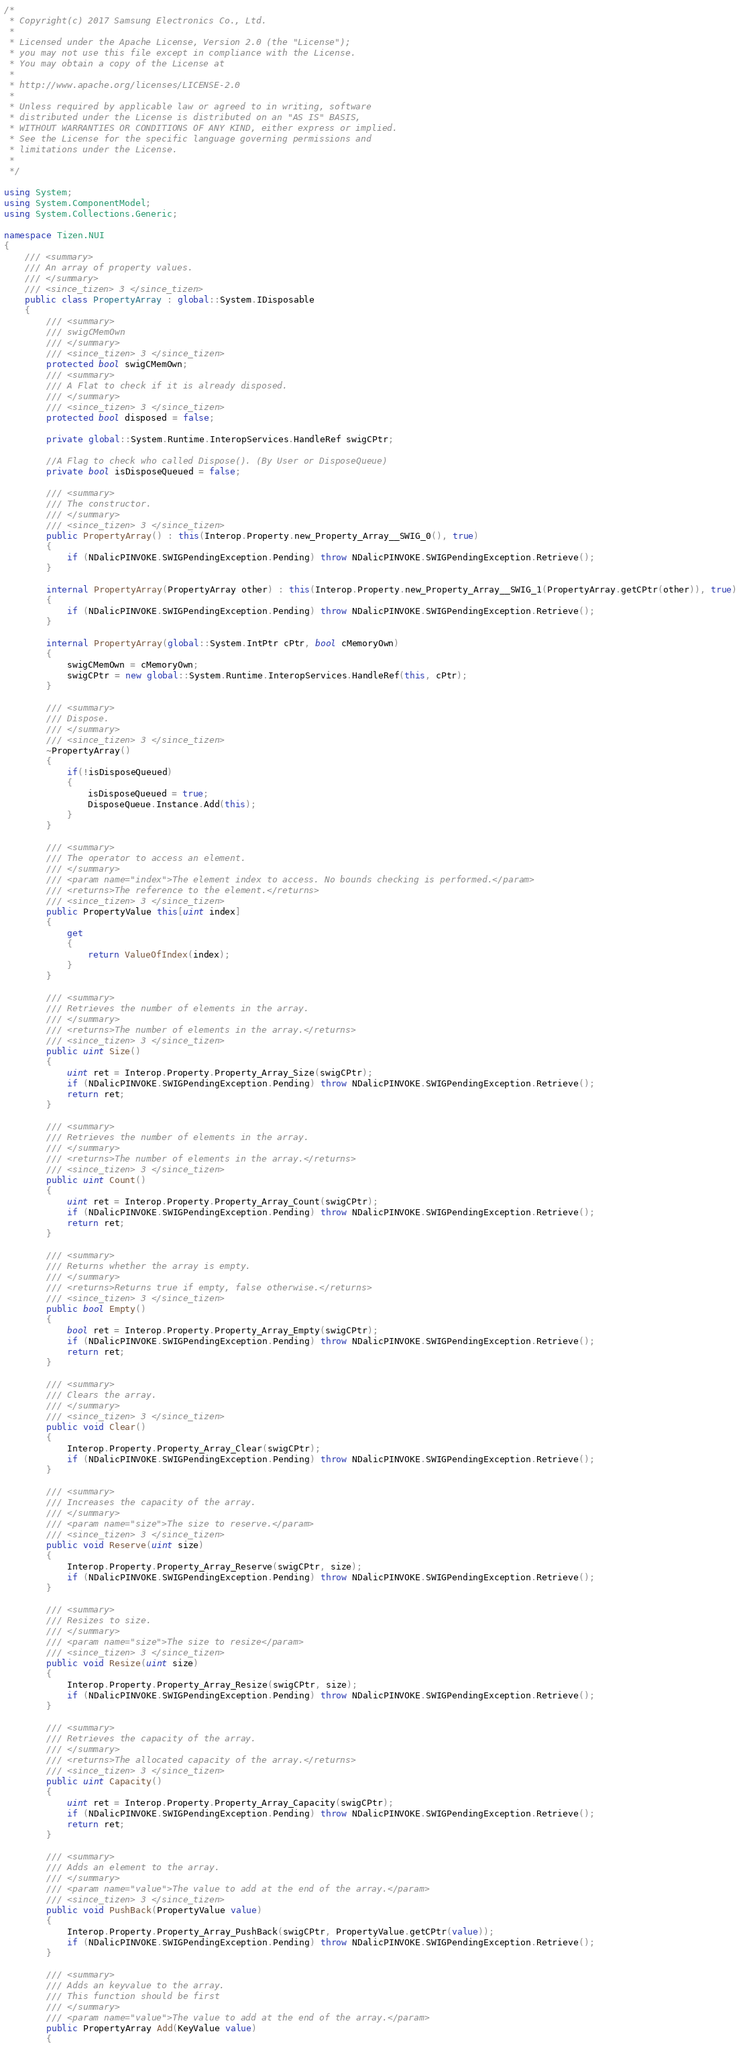Convert code to text. <code><loc_0><loc_0><loc_500><loc_500><_C#_>/*
 * Copyright(c) 2017 Samsung Electronics Co., Ltd.
 *
 * Licensed under the Apache License, Version 2.0 (the "License");
 * you may not use this file except in compliance with the License.
 * You may obtain a copy of the License at
 *
 * http://www.apache.org/licenses/LICENSE-2.0
 *
 * Unless required by applicable law or agreed to in writing, software
 * distributed under the License is distributed on an "AS IS" BASIS,
 * WITHOUT WARRANTIES OR CONDITIONS OF ANY KIND, either express or implied.
 * See the License for the specific language governing permissions and
 * limitations under the License.
 *
 */

using System;
using System.ComponentModel;
using System.Collections.Generic;

namespace Tizen.NUI
{
    /// <summary>
    /// An array of property values.
    /// </summary>
    /// <since_tizen> 3 </since_tizen>
    public class PropertyArray : global::System.IDisposable
    {
        /// <summary>
        /// swigCMemOwn
        /// </summary>
        /// <since_tizen> 3 </since_tizen>
        protected bool swigCMemOwn;
        /// <summary>
        /// A Flat to check if it is already disposed.
        /// </summary>
        /// <since_tizen> 3 </since_tizen>
        protected bool disposed = false;

        private global::System.Runtime.InteropServices.HandleRef swigCPtr;

        //A Flag to check who called Dispose(). (By User or DisposeQueue)
        private bool isDisposeQueued = false;

        /// <summary>
        /// The constructor.
        /// </summary>
        /// <since_tizen> 3 </since_tizen>
        public PropertyArray() : this(Interop.Property.new_Property_Array__SWIG_0(), true)
        {
            if (NDalicPINVOKE.SWIGPendingException.Pending) throw NDalicPINVOKE.SWIGPendingException.Retrieve();
        }

        internal PropertyArray(PropertyArray other) : this(Interop.Property.new_Property_Array__SWIG_1(PropertyArray.getCPtr(other)), true)
        {
            if (NDalicPINVOKE.SWIGPendingException.Pending) throw NDalicPINVOKE.SWIGPendingException.Retrieve();
        }

        internal PropertyArray(global::System.IntPtr cPtr, bool cMemoryOwn)
        {
            swigCMemOwn = cMemoryOwn;
            swigCPtr = new global::System.Runtime.InteropServices.HandleRef(this, cPtr);
        }

        /// <summary>
        /// Dispose.
        /// </summary>
        /// <since_tizen> 3 </since_tizen>
        ~PropertyArray()
        {
            if(!isDisposeQueued)
            {
                isDisposeQueued = true;
                DisposeQueue.Instance.Add(this);
            }
        }

        /// <summary>
        /// The operator to access an element.
        /// </summary>
        /// <param name="index">The element index to access. No bounds checking is performed.</param>
        /// <returns>The reference to the element.</returns>
        /// <since_tizen> 3 </since_tizen>
        public PropertyValue this[uint index]
        {
            get
            {
                return ValueOfIndex(index);
            }
        }

        /// <summary>
        /// Retrieves the number of elements in the array.
        /// </summary>
        /// <returns>The number of elements in the array.</returns>
        /// <since_tizen> 3 </since_tizen>
        public uint Size()
        {
            uint ret = Interop.Property.Property_Array_Size(swigCPtr);
            if (NDalicPINVOKE.SWIGPendingException.Pending) throw NDalicPINVOKE.SWIGPendingException.Retrieve();
            return ret;
        }

        /// <summary>
        /// Retrieves the number of elements in the array.
        /// </summary>
        /// <returns>The number of elements in the array.</returns>
        /// <since_tizen> 3 </since_tizen>
        public uint Count()
        {
            uint ret = Interop.Property.Property_Array_Count(swigCPtr);
            if (NDalicPINVOKE.SWIGPendingException.Pending) throw NDalicPINVOKE.SWIGPendingException.Retrieve();
            return ret;
        }

        /// <summary>
        /// Returns whether the array is empty.
        /// </summary>
        /// <returns>Returns true if empty, false otherwise.</returns>
        /// <since_tizen> 3 </since_tizen>
        public bool Empty()
        {
            bool ret = Interop.Property.Property_Array_Empty(swigCPtr);
            if (NDalicPINVOKE.SWIGPendingException.Pending) throw NDalicPINVOKE.SWIGPendingException.Retrieve();
            return ret;
        }

        /// <summary>
        /// Clears the array.
        /// </summary>
        /// <since_tizen> 3 </since_tizen>
        public void Clear()
        {
            Interop.Property.Property_Array_Clear(swigCPtr);
            if (NDalicPINVOKE.SWIGPendingException.Pending) throw NDalicPINVOKE.SWIGPendingException.Retrieve();
        }

        /// <summary>
        /// Increases the capacity of the array.
        /// </summary>
        /// <param name="size">The size to reserve.</param>
        /// <since_tizen> 3 </since_tizen>
        public void Reserve(uint size)
        {
            Interop.Property.Property_Array_Reserve(swigCPtr, size);
            if (NDalicPINVOKE.SWIGPendingException.Pending) throw NDalicPINVOKE.SWIGPendingException.Retrieve();
        }

        /// <summary>
        /// Resizes to size.
        /// </summary>
        /// <param name="size">The size to resize</param>
        /// <since_tizen> 3 </since_tizen>
        public void Resize(uint size)
        {
            Interop.Property.Property_Array_Resize(swigCPtr, size);
            if (NDalicPINVOKE.SWIGPendingException.Pending) throw NDalicPINVOKE.SWIGPendingException.Retrieve();
        }

        /// <summary>
        /// Retrieves the capacity of the array.
        /// </summary>
        /// <returns>The allocated capacity of the array.</returns>
        /// <since_tizen> 3 </since_tizen>
        public uint Capacity()
        {
            uint ret = Interop.Property.Property_Array_Capacity(swigCPtr);
            if (NDalicPINVOKE.SWIGPendingException.Pending) throw NDalicPINVOKE.SWIGPendingException.Retrieve();
            return ret;
        }

        /// <summary>
        /// Adds an element to the array.
        /// </summary>
        /// <param name="value">The value to add at the end of the array.</param>
        /// <since_tizen> 3 </since_tizen>
        public void PushBack(PropertyValue value)
        {
            Interop.Property.Property_Array_PushBack(swigCPtr, PropertyValue.getCPtr(value));
            if (NDalicPINVOKE.SWIGPendingException.Pending) throw NDalicPINVOKE.SWIGPendingException.Retrieve();
        }

        /// <summary>
        /// Adds an keyvalue to the array.
        /// This function should be first
        /// </summary>
        /// <param name="value">The value to add at the end of the array.</param>
        public PropertyArray Add(KeyValue value)
        {</code> 